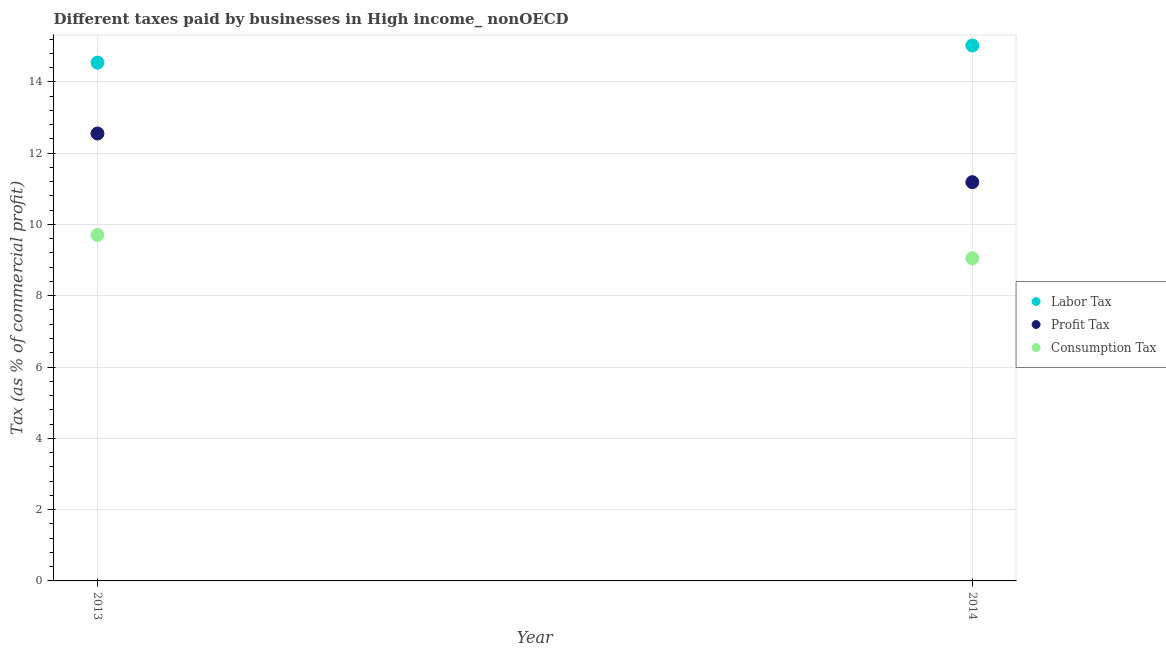How many different coloured dotlines are there?
Offer a terse response. 3. Is the number of dotlines equal to the number of legend labels?
Keep it short and to the point. Yes. What is the percentage of consumption tax in 2014?
Offer a terse response. 9.05. Across all years, what is the maximum percentage of profit tax?
Give a very brief answer. 12.55. Across all years, what is the minimum percentage of labor tax?
Provide a short and direct response. 14.54. In which year was the percentage of profit tax maximum?
Provide a short and direct response. 2013. In which year was the percentage of labor tax minimum?
Your answer should be very brief. 2013. What is the total percentage of consumption tax in the graph?
Make the answer very short. 18.76. What is the difference between the percentage of labor tax in 2013 and that in 2014?
Ensure brevity in your answer.  -0.48. What is the difference between the percentage of labor tax in 2014 and the percentage of profit tax in 2013?
Ensure brevity in your answer.  2.47. What is the average percentage of consumption tax per year?
Offer a very short reply. 9.38. In the year 2013, what is the difference between the percentage of labor tax and percentage of profit tax?
Offer a very short reply. 1.99. In how many years, is the percentage of profit tax greater than 11.2 %?
Give a very brief answer. 1. What is the ratio of the percentage of profit tax in 2013 to that in 2014?
Your response must be concise. 1.12. Is the percentage of consumption tax in 2013 less than that in 2014?
Make the answer very short. No. In how many years, is the percentage of profit tax greater than the average percentage of profit tax taken over all years?
Give a very brief answer. 1. Does the percentage of profit tax monotonically increase over the years?
Keep it short and to the point. No. Is the percentage of labor tax strictly greater than the percentage of consumption tax over the years?
Offer a very short reply. Yes. How many years are there in the graph?
Offer a very short reply. 2. Are the values on the major ticks of Y-axis written in scientific E-notation?
Your answer should be compact. No. Where does the legend appear in the graph?
Make the answer very short. Center right. How are the legend labels stacked?
Offer a very short reply. Vertical. What is the title of the graph?
Provide a short and direct response. Different taxes paid by businesses in High income_ nonOECD. Does "Tertiary education" appear as one of the legend labels in the graph?
Your answer should be compact. No. What is the label or title of the Y-axis?
Ensure brevity in your answer.  Tax (as % of commercial profit). What is the Tax (as % of commercial profit) of Labor Tax in 2013?
Provide a succinct answer. 14.54. What is the Tax (as % of commercial profit) of Profit Tax in 2013?
Your answer should be compact. 12.55. What is the Tax (as % of commercial profit) in Consumption Tax in 2013?
Your answer should be very brief. 9.7. What is the Tax (as % of commercial profit) of Labor Tax in 2014?
Offer a very short reply. 15.02. What is the Tax (as % of commercial profit) of Profit Tax in 2014?
Offer a very short reply. 11.19. What is the Tax (as % of commercial profit) in Consumption Tax in 2014?
Make the answer very short. 9.05. Across all years, what is the maximum Tax (as % of commercial profit) in Labor Tax?
Ensure brevity in your answer.  15.02. Across all years, what is the maximum Tax (as % of commercial profit) in Profit Tax?
Offer a terse response. 12.55. Across all years, what is the maximum Tax (as % of commercial profit) of Consumption Tax?
Your answer should be very brief. 9.7. Across all years, what is the minimum Tax (as % of commercial profit) in Labor Tax?
Offer a very short reply. 14.54. Across all years, what is the minimum Tax (as % of commercial profit) of Profit Tax?
Your answer should be compact. 11.19. Across all years, what is the minimum Tax (as % of commercial profit) in Consumption Tax?
Keep it short and to the point. 9.05. What is the total Tax (as % of commercial profit) of Labor Tax in the graph?
Your response must be concise. 29.56. What is the total Tax (as % of commercial profit) in Profit Tax in the graph?
Give a very brief answer. 23.74. What is the total Tax (as % of commercial profit) in Consumption Tax in the graph?
Keep it short and to the point. 18.76. What is the difference between the Tax (as % of commercial profit) of Labor Tax in 2013 and that in 2014?
Keep it short and to the point. -0.48. What is the difference between the Tax (as % of commercial profit) in Profit Tax in 2013 and that in 2014?
Give a very brief answer. 1.36. What is the difference between the Tax (as % of commercial profit) of Consumption Tax in 2013 and that in 2014?
Ensure brevity in your answer.  0.65. What is the difference between the Tax (as % of commercial profit) in Labor Tax in 2013 and the Tax (as % of commercial profit) in Profit Tax in 2014?
Your answer should be compact. 3.35. What is the difference between the Tax (as % of commercial profit) in Labor Tax in 2013 and the Tax (as % of commercial profit) in Consumption Tax in 2014?
Provide a succinct answer. 5.49. What is the difference between the Tax (as % of commercial profit) in Profit Tax in 2013 and the Tax (as % of commercial profit) in Consumption Tax in 2014?
Provide a short and direct response. 3.5. What is the average Tax (as % of commercial profit) of Labor Tax per year?
Offer a very short reply. 14.78. What is the average Tax (as % of commercial profit) in Profit Tax per year?
Ensure brevity in your answer.  11.87. What is the average Tax (as % of commercial profit) in Consumption Tax per year?
Provide a succinct answer. 9.38. In the year 2013, what is the difference between the Tax (as % of commercial profit) of Labor Tax and Tax (as % of commercial profit) of Profit Tax?
Give a very brief answer. 1.99. In the year 2013, what is the difference between the Tax (as % of commercial profit) in Labor Tax and Tax (as % of commercial profit) in Consumption Tax?
Ensure brevity in your answer.  4.83. In the year 2013, what is the difference between the Tax (as % of commercial profit) in Profit Tax and Tax (as % of commercial profit) in Consumption Tax?
Your response must be concise. 2.85. In the year 2014, what is the difference between the Tax (as % of commercial profit) of Labor Tax and Tax (as % of commercial profit) of Profit Tax?
Your response must be concise. 3.83. In the year 2014, what is the difference between the Tax (as % of commercial profit) of Labor Tax and Tax (as % of commercial profit) of Consumption Tax?
Your answer should be very brief. 5.97. In the year 2014, what is the difference between the Tax (as % of commercial profit) of Profit Tax and Tax (as % of commercial profit) of Consumption Tax?
Offer a terse response. 2.13. What is the ratio of the Tax (as % of commercial profit) of Labor Tax in 2013 to that in 2014?
Provide a succinct answer. 0.97. What is the ratio of the Tax (as % of commercial profit) in Profit Tax in 2013 to that in 2014?
Ensure brevity in your answer.  1.12. What is the ratio of the Tax (as % of commercial profit) of Consumption Tax in 2013 to that in 2014?
Provide a short and direct response. 1.07. What is the difference between the highest and the second highest Tax (as % of commercial profit) in Labor Tax?
Your response must be concise. 0.48. What is the difference between the highest and the second highest Tax (as % of commercial profit) of Profit Tax?
Your answer should be compact. 1.36. What is the difference between the highest and the second highest Tax (as % of commercial profit) of Consumption Tax?
Your answer should be very brief. 0.65. What is the difference between the highest and the lowest Tax (as % of commercial profit) in Labor Tax?
Your answer should be compact. 0.48. What is the difference between the highest and the lowest Tax (as % of commercial profit) of Profit Tax?
Your answer should be very brief. 1.36. What is the difference between the highest and the lowest Tax (as % of commercial profit) in Consumption Tax?
Ensure brevity in your answer.  0.65. 